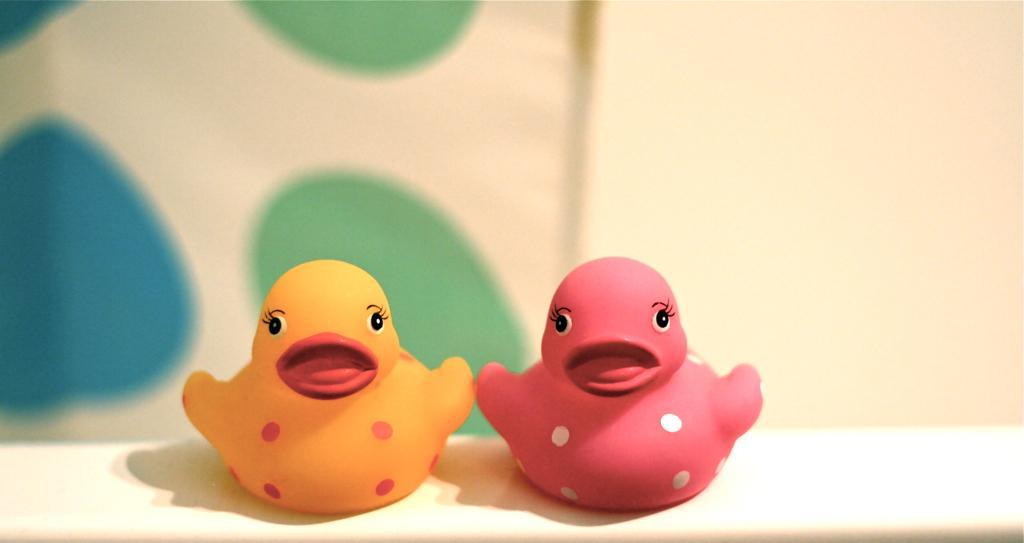Can you describe this image briefly? In this picture we can observe two toys which were in pink and yellow color placed on the white color desk. In the background there is a wall which is in white color. 